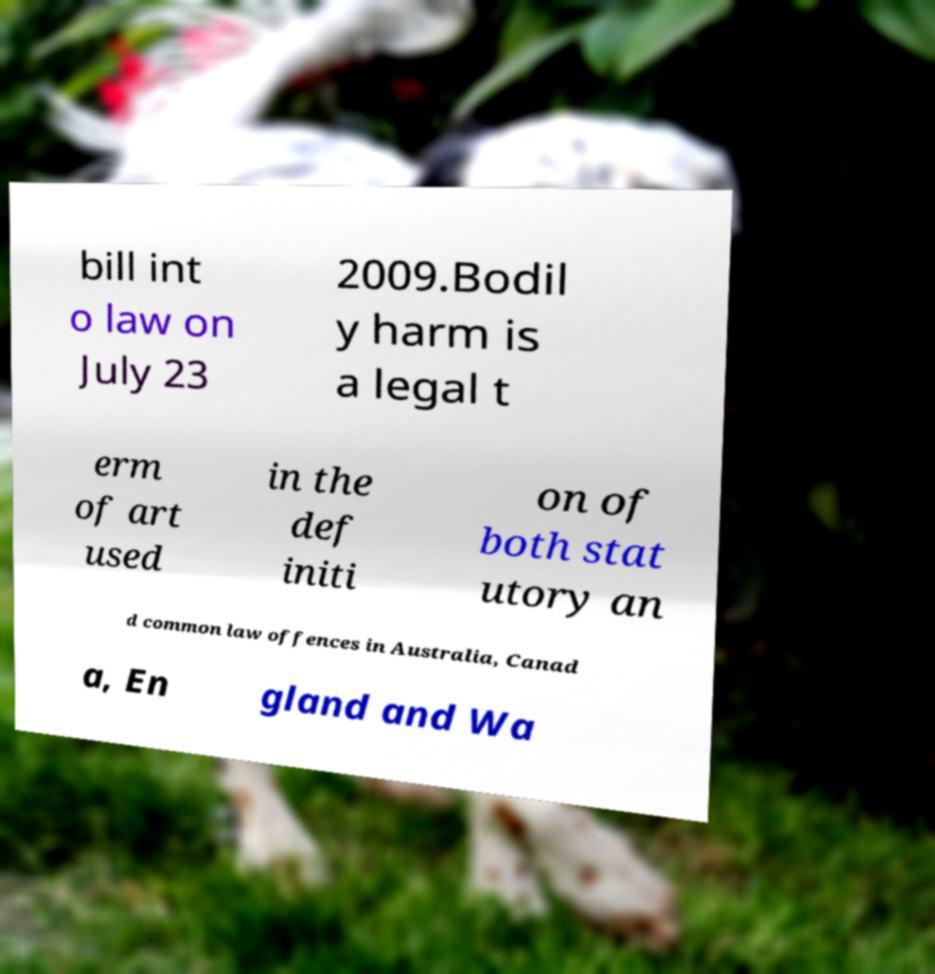For documentation purposes, I need the text within this image transcribed. Could you provide that? bill int o law on July 23 2009.Bodil y harm is a legal t erm of art used in the def initi on of both stat utory an d common law offences in Australia, Canad a, En gland and Wa 